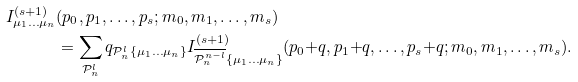Convert formula to latex. <formula><loc_0><loc_0><loc_500><loc_500>I ^ { ( s + 1 ) } _ { \mu _ { 1 } \dots \mu _ { n } } & ( p _ { 0 } , p _ { 1 } , \dots , p _ { s } ; m _ { 0 } , m _ { 1 } , \dots , m _ { s } ) \\ & = \sum _ { \mathcal { P } ^ { l } _ { n } } q _ { \mathcal { P } ^ { l } _ { n } \{ \mu _ { 1 } \dots \mu _ { n } \} } I ^ { ( s + 1 ) } _ { \overline { \mathcal { P } ^ { n - l } _ { n } } \{ \mu _ { 1 } \dots \mu _ { n } \} } ( p _ { 0 } { + } q , p _ { 1 } { + } q , \dots , p _ { s } { + } q ; m _ { 0 } , m _ { 1 } , \dots , m _ { s } ) .</formula> 